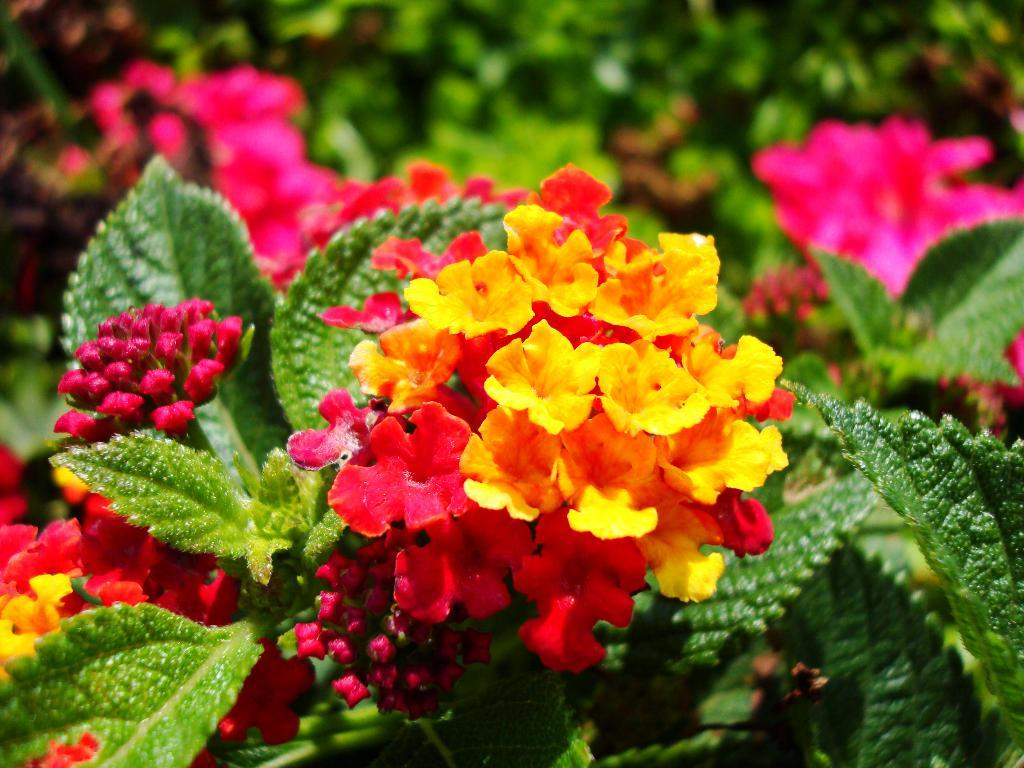What type of plants are visible in the image? There are colorful flowers and green leaves in the image. What color dominates the background of the image? The background of the image is green. How many planes can be seen flying over the flowers in the image? There are no planes visible in the image; it only features flowers and leaves. What type of crayon is used to color the flowers in the image? The image is a photograph and does not involve the use of crayons; it is a representation of real flowers and leaves. 